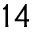<formula> <loc_0><loc_0><loc_500><loc_500>^ { 1 4 }</formula> 